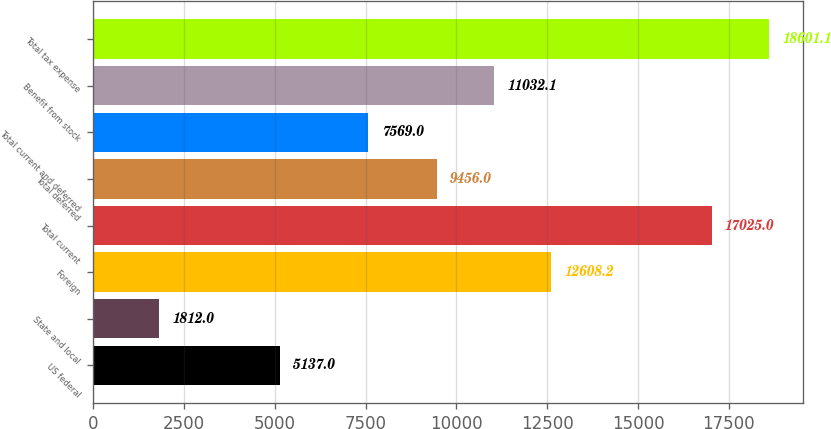Convert chart to OTSL. <chart><loc_0><loc_0><loc_500><loc_500><bar_chart><fcel>US federal<fcel>State and local<fcel>Foreign<fcel>Total current<fcel>Total deferred<fcel>Total current and deferred<fcel>Benefit from stock<fcel>Total tax expense<nl><fcel>5137<fcel>1812<fcel>12608.2<fcel>17025<fcel>9456<fcel>7569<fcel>11032.1<fcel>18601.1<nl></chart> 